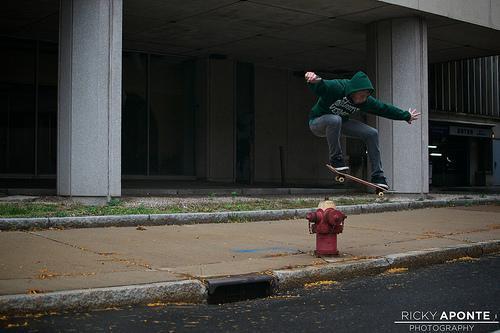How many people are there?
Give a very brief answer. 1. 